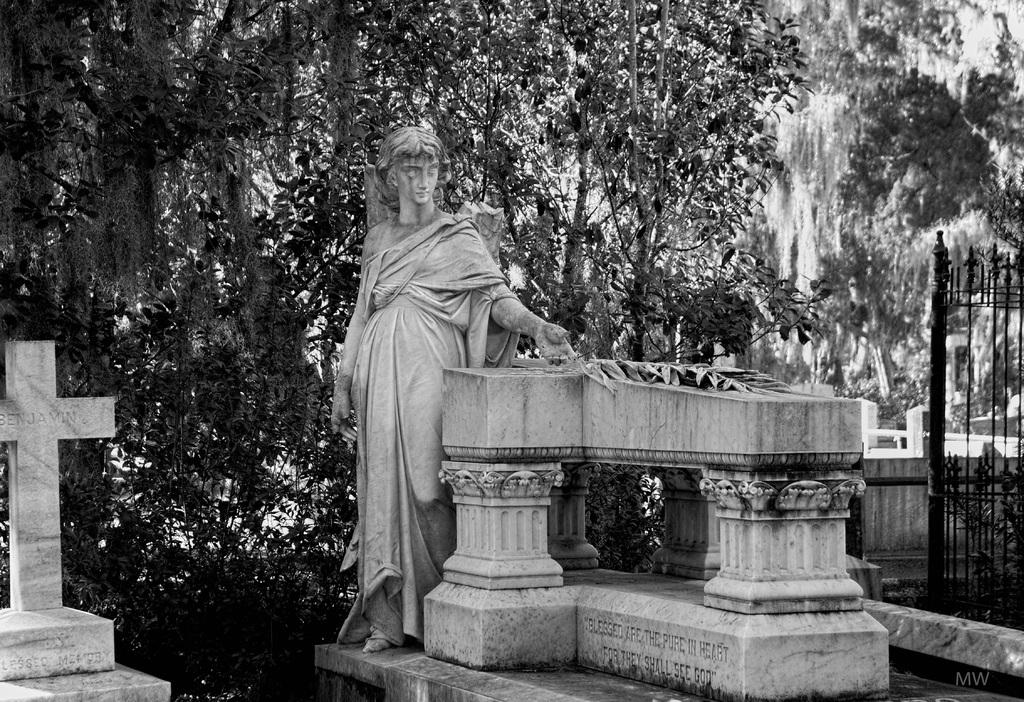What is the color scheme of the image? The image is black and white. What types of art are present in the image? There are statues and sculptures in the image. What architectural features can be seen in the image? There are grills in the image. What type of natural elements are visible in the image? There are trees and plants in the image. Can you see a cup floating in space in the image? There is no cup or space present in the image; it features statues, sculptures, grills, trees, and plants. 